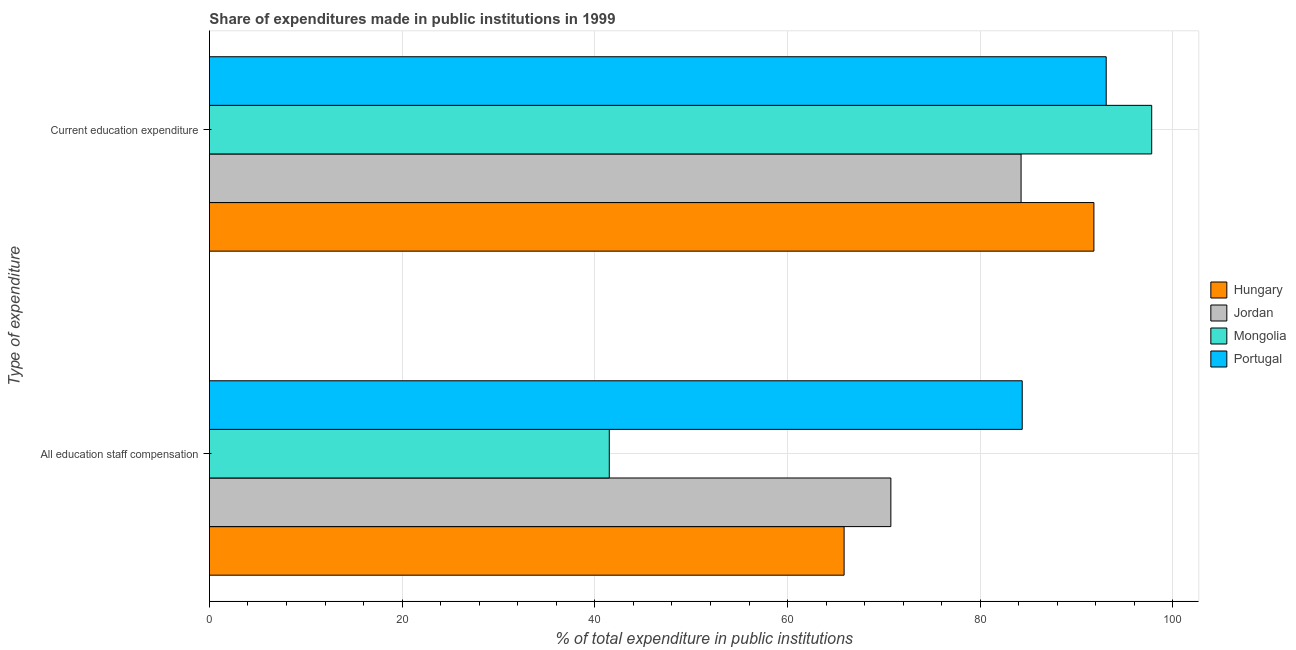How many different coloured bars are there?
Your answer should be very brief. 4. Are the number of bars per tick equal to the number of legend labels?
Your response must be concise. Yes. Are the number of bars on each tick of the Y-axis equal?
Your answer should be very brief. Yes. How many bars are there on the 2nd tick from the top?
Make the answer very short. 4. How many bars are there on the 1st tick from the bottom?
Provide a short and direct response. 4. What is the label of the 1st group of bars from the top?
Provide a short and direct response. Current education expenditure. What is the expenditure in staff compensation in Jordan?
Keep it short and to the point. 70.72. Across all countries, what is the maximum expenditure in staff compensation?
Ensure brevity in your answer.  84.36. Across all countries, what is the minimum expenditure in education?
Keep it short and to the point. 84.24. In which country was the expenditure in staff compensation maximum?
Your answer should be very brief. Portugal. In which country was the expenditure in education minimum?
Provide a succinct answer. Jordan. What is the total expenditure in staff compensation in the graph?
Your response must be concise. 262.45. What is the difference between the expenditure in education in Mongolia and that in Hungary?
Offer a very short reply. 6. What is the difference between the expenditure in staff compensation in Portugal and the expenditure in education in Mongolia?
Your answer should be very brief. -13.44. What is the average expenditure in staff compensation per country?
Make the answer very short. 65.61. What is the difference between the expenditure in staff compensation and expenditure in education in Hungary?
Offer a very short reply. -25.93. What is the ratio of the expenditure in staff compensation in Hungary to that in Jordan?
Provide a succinct answer. 0.93. What does the 1st bar from the top in Current education expenditure represents?
Your response must be concise. Portugal. What does the 3rd bar from the bottom in All education staff compensation represents?
Your answer should be very brief. Mongolia. How many bars are there?
Make the answer very short. 8. Are all the bars in the graph horizontal?
Offer a very short reply. Yes. How many countries are there in the graph?
Your answer should be compact. 4. What is the difference between two consecutive major ticks on the X-axis?
Ensure brevity in your answer.  20. Does the graph contain any zero values?
Offer a very short reply. No. Does the graph contain grids?
Ensure brevity in your answer.  Yes. How are the legend labels stacked?
Offer a terse response. Vertical. What is the title of the graph?
Your response must be concise. Share of expenditures made in public institutions in 1999. Does "Qatar" appear as one of the legend labels in the graph?
Provide a succinct answer. No. What is the label or title of the X-axis?
Provide a succinct answer. % of total expenditure in public institutions. What is the label or title of the Y-axis?
Your answer should be very brief. Type of expenditure. What is the % of total expenditure in public institutions of Hungary in All education staff compensation?
Your response must be concise. 65.87. What is the % of total expenditure in public institutions of Jordan in All education staff compensation?
Offer a very short reply. 70.72. What is the % of total expenditure in public institutions in Mongolia in All education staff compensation?
Your answer should be compact. 41.5. What is the % of total expenditure in public institutions in Portugal in All education staff compensation?
Offer a terse response. 84.36. What is the % of total expenditure in public institutions in Hungary in Current education expenditure?
Offer a terse response. 91.8. What is the % of total expenditure in public institutions in Jordan in Current education expenditure?
Give a very brief answer. 84.24. What is the % of total expenditure in public institutions in Mongolia in Current education expenditure?
Offer a terse response. 97.79. What is the % of total expenditure in public institutions of Portugal in Current education expenditure?
Offer a terse response. 93.07. Across all Type of expenditure, what is the maximum % of total expenditure in public institutions in Hungary?
Offer a very short reply. 91.8. Across all Type of expenditure, what is the maximum % of total expenditure in public institutions in Jordan?
Keep it short and to the point. 84.24. Across all Type of expenditure, what is the maximum % of total expenditure in public institutions of Mongolia?
Offer a terse response. 97.79. Across all Type of expenditure, what is the maximum % of total expenditure in public institutions of Portugal?
Offer a terse response. 93.07. Across all Type of expenditure, what is the minimum % of total expenditure in public institutions in Hungary?
Provide a succinct answer. 65.87. Across all Type of expenditure, what is the minimum % of total expenditure in public institutions in Jordan?
Provide a succinct answer. 70.72. Across all Type of expenditure, what is the minimum % of total expenditure in public institutions in Mongolia?
Your answer should be very brief. 41.5. Across all Type of expenditure, what is the minimum % of total expenditure in public institutions in Portugal?
Give a very brief answer. 84.36. What is the total % of total expenditure in public institutions in Hungary in the graph?
Offer a very short reply. 157.67. What is the total % of total expenditure in public institutions of Jordan in the graph?
Make the answer very short. 154.96. What is the total % of total expenditure in public institutions of Mongolia in the graph?
Keep it short and to the point. 139.29. What is the total % of total expenditure in public institutions in Portugal in the graph?
Your response must be concise. 177.43. What is the difference between the % of total expenditure in public institutions in Hungary in All education staff compensation and that in Current education expenditure?
Your answer should be very brief. -25.93. What is the difference between the % of total expenditure in public institutions of Jordan in All education staff compensation and that in Current education expenditure?
Ensure brevity in your answer.  -13.51. What is the difference between the % of total expenditure in public institutions of Mongolia in All education staff compensation and that in Current education expenditure?
Provide a short and direct response. -56.3. What is the difference between the % of total expenditure in public institutions of Portugal in All education staff compensation and that in Current education expenditure?
Make the answer very short. -8.72. What is the difference between the % of total expenditure in public institutions of Hungary in All education staff compensation and the % of total expenditure in public institutions of Jordan in Current education expenditure?
Give a very brief answer. -18.37. What is the difference between the % of total expenditure in public institutions of Hungary in All education staff compensation and the % of total expenditure in public institutions of Mongolia in Current education expenditure?
Make the answer very short. -31.92. What is the difference between the % of total expenditure in public institutions of Hungary in All education staff compensation and the % of total expenditure in public institutions of Portugal in Current education expenditure?
Your answer should be very brief. -27.2. What is the difference between the % of total expenditure in public institutions in Jordan in All education staff compensation and the % of total expenditure in public institutions in Mongolia in Current education expenditure?
Provide a succinct answer. -27.07. What is the difference between the % of total expenditure in public institutions in Jordan in All education staff compensation and the % of total expenditure in public institutions in Portugal in Current education expenditure?
Provide a short and direct response. -22.35. What is the difference between the % of total expenditure in public institutions in Mongolia in All education staff compensation and the % of total expenditure in public institutions in Portugal in Current education expenditure?
Give a very brief answer. -51.57. What is the average % of total expenditure in public institutions in Hungary per Type of expenditure?
Keep it short and to the point. 78.83. What is the average % of total expenditure in public institutions of Jordan per Type of expenditure?
Your answer should be compact. 77.48. What is the average % of total expenditure in public institutions of Mongolia per Type of expenditure?
Ensure brevity in your answer.  69.65. What is the average % of total expenditure in public institutions of Portugal per Type of expenditure?
Offer a terse response. 88.71. What is the difference between the % of total expenditure in public institutions of Hungary and % of total expenditure in public institutions of Jordan in All education staff compensation?
Your response must be concise. -4.85. What is the difference between the % of total expenditure in public institutions of Hungary and % of total expenditure in public institutions of Mongolia in All education staff compensation?
Offer a terse response. 24.37. What is the difference between the % of total expenditure in public institutions of Hungary and % of total expenditure in public institutions of Portugal in All education staff compensation?
Your answer should be very brief. -18.49. What is the difference between the % of total expenditure in public institutions in Jordan and % of total expenditure in public institutions in Mongolia in All education staff compensation?
Your answer should be very brief. 29.22. What is the difference between the % of total expenditure in public institutions in Jordan and % of total expenditure in public institutions in Portugal in All education staff compensation?
Your response must be concise. -13.63. What is the difference between the % of total expenditure in public institutions of Mongolia and % of total expenditure in public institutions of Portugal in All education staff compensation?
Your response must be concise. -42.86. What is the difference between the % of total expenditure in public institutions of Hungary and % of total expenditure in public institutions of Jordan in Current education expenditure?
Make the answer very short. 7.56. What is the difference between the % of total expenditure in public institutions of Hungary and % of total expenditure in public institutions of Mongolia in Current education expenditure?
Provide a succinct answer. -6. What is the difference between the % of total expenditure in public institutions of Hungary and % of total expenditure in public institutions of Portugal in Current education expenditure?
Your answer should be compact. -1.28. What is the difference between the % of total expenditure in public institutions of Jordan and % of total expenditure in public institutions of Mongolia in Current education expenditure?
Your answer should be very brief. -13.56. What is the difference between the % of total expenditure in public institutions of Jordan and % of total expenditure in public institutions of Portugal in Current education expenditure?
Provide a short and direct response. -8.83. What is the difference between the % of total expenditure in public institutions of Mongolia and % of total expenditure in public institutions of Portugal in Current education expenditure?
Make the answer very short. 4.72. What is the ratio of the % of total expenditure in public institutions in Hungary in All education staff compensation to that in Current education expenditure?
Give a very brief answer. 0.72. What is the ratio of the % of total expenditure in public institutions in Jordan in All education staff compensation to that in Current education expenditure?
Provide a short and direct response. 0.84. What is the ratio of the % of total expenditure in public institutions in Mongolia in All education staff compensation to that in Current education expenditure?
Ensure brevity in your answer.  0.42. What is the ratio of the % of total expenditure in public institutions of Portugal in All education staff compensation to that in Current education expenditure?
Your response must be concise. 0.91. What is the difference between the highest and the second highest % of total expenditure in public institutions of Hungary?
Keep it short and to the point. 25.93. What is the difference between the highest and the second highest % of total expenditure in public institutions in Jordan?
Your answer should be compact. 13.51. What is the difference between the highest and the second highest % of total expenditure in public institutions of Mongolia?
Offer a very short reply. 56.3. What is the difference between the highest and the second highest % of total expenditure in public institutions in Portugal?
Provide a short and direct response. 8.72. What is the difference between the highest and the lowest % of total expenditure in public institutions in Hungary?
Offer a very short reply. 25.93. What is the difference between the highest and the lowest % of total expenditure in public institutions in Jordan?
Your answer should be very brief. 13.51. What is the difference between the highest and the lowest % of total expenditure in public institutions in Mongolia?
Ensure brevity in your answer.  56.3. What is the difference between the highest and the lowest % of total expenditure in public institutions of Portugal?
Provide a short and direct response. 8.72. 